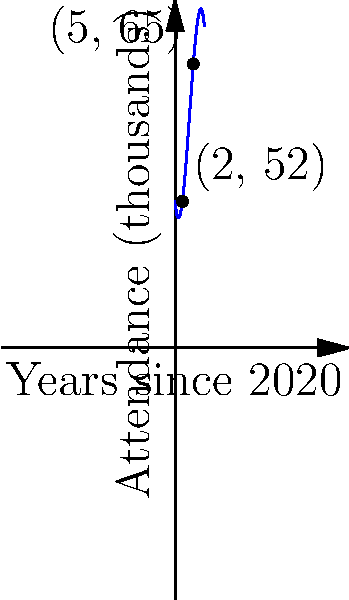As a Czech sports journalist covering women's sports, you're analyzing the attendance growth of a major women's ice hockey tournament. The attendance (in thousands) since 2020 can be modeled by the function $f(x) = -0.5x^3 + 6x^2 - 10x + 40$, where $x$ represents the number of years since 2020. Based on this model, in which year will the tournament reach its peak attendance, and what will that attendance be? To find the year of peak attendance and its value, we need to follow these steps:

1) The peak attendance will occur at the maximum point of the function. To find this, we need to calculate the derivative and set it to zero.

2) The derivative of $f(x) = -0.5x^3 + 6x^2 - 10x + 40$ is:
   $f'(x) = -1.5x^2 + 12x - 10$

3) Set $f'(x) = 0$ and solve:
   $-1.5x^2 + 12x - 10 = 0$
   
4) This is a quadratic equation. We can solve it using the quadratic formula:
   $x = \frac{-b \pm \sqrt{b^2 - 4ac}}{2a}$
   
   Where $a = -1.5$, $b = 12$, and $c = -10$

5) Plugging in these values:
   $x = \frac{-12 \pm \sqrt{12^2 - 4(-1.5)(-10)}}{2(-1.5)}$
   $= \frac{-12 \pm \sqrt{144 - 60}}{-3}$
   $= \frac{-12 \pm \sqrt{84}}{-3}$
   $= \frac{-12 \pm 9.17}{-3}$

6) This gives us two solutions: $x \approx 4$ or $x \approx 0.67$

7) Since we're looking for the maximum, we choose $x \approx 4$

8) This means the peak occurs 4 years after 2020, which is 2024.

9) To find the attendance at this peak, we plug $x = 4$ into our original function:
   $f(4) = -0.5(4)^3 + 6(4)^2 - 10(4) + 40$
   $= -32 + 96 - 40 + 40$
   $= 64$

Therefore, the peak attendance of 64,000 will occur in 2024.
Answer: 2024 with 64,000 attendees 